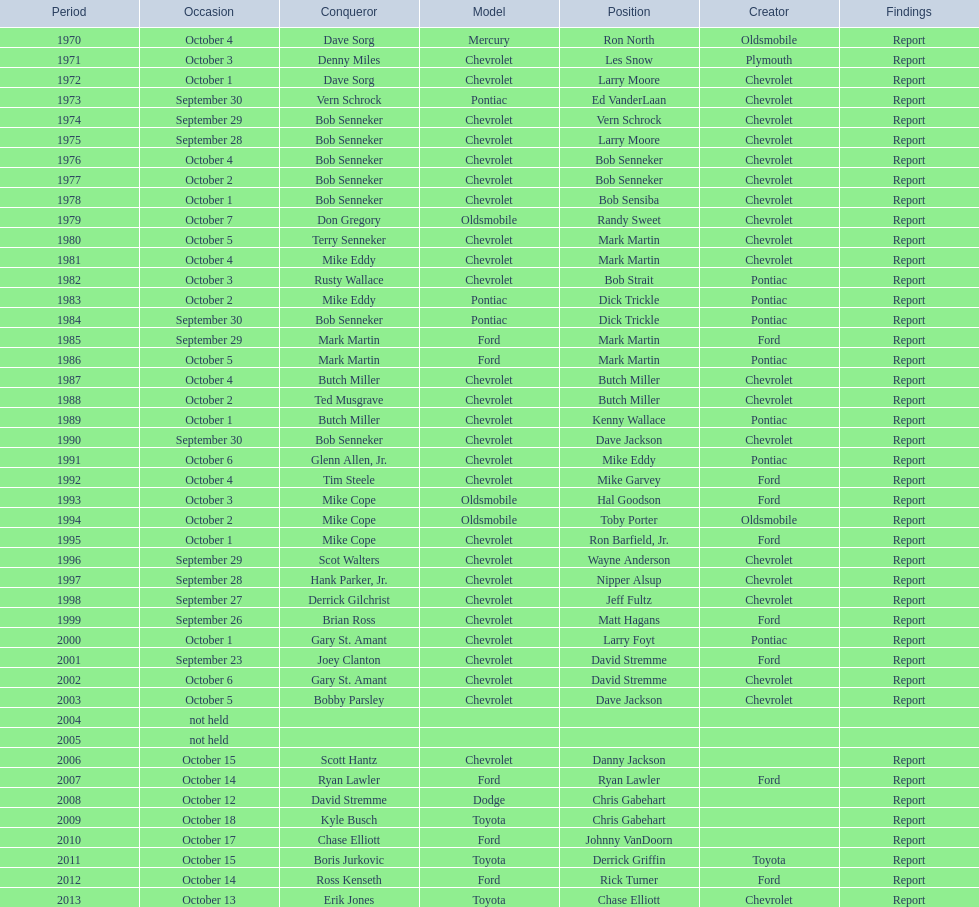How many consecutive wins did bob senneker have? 5. 